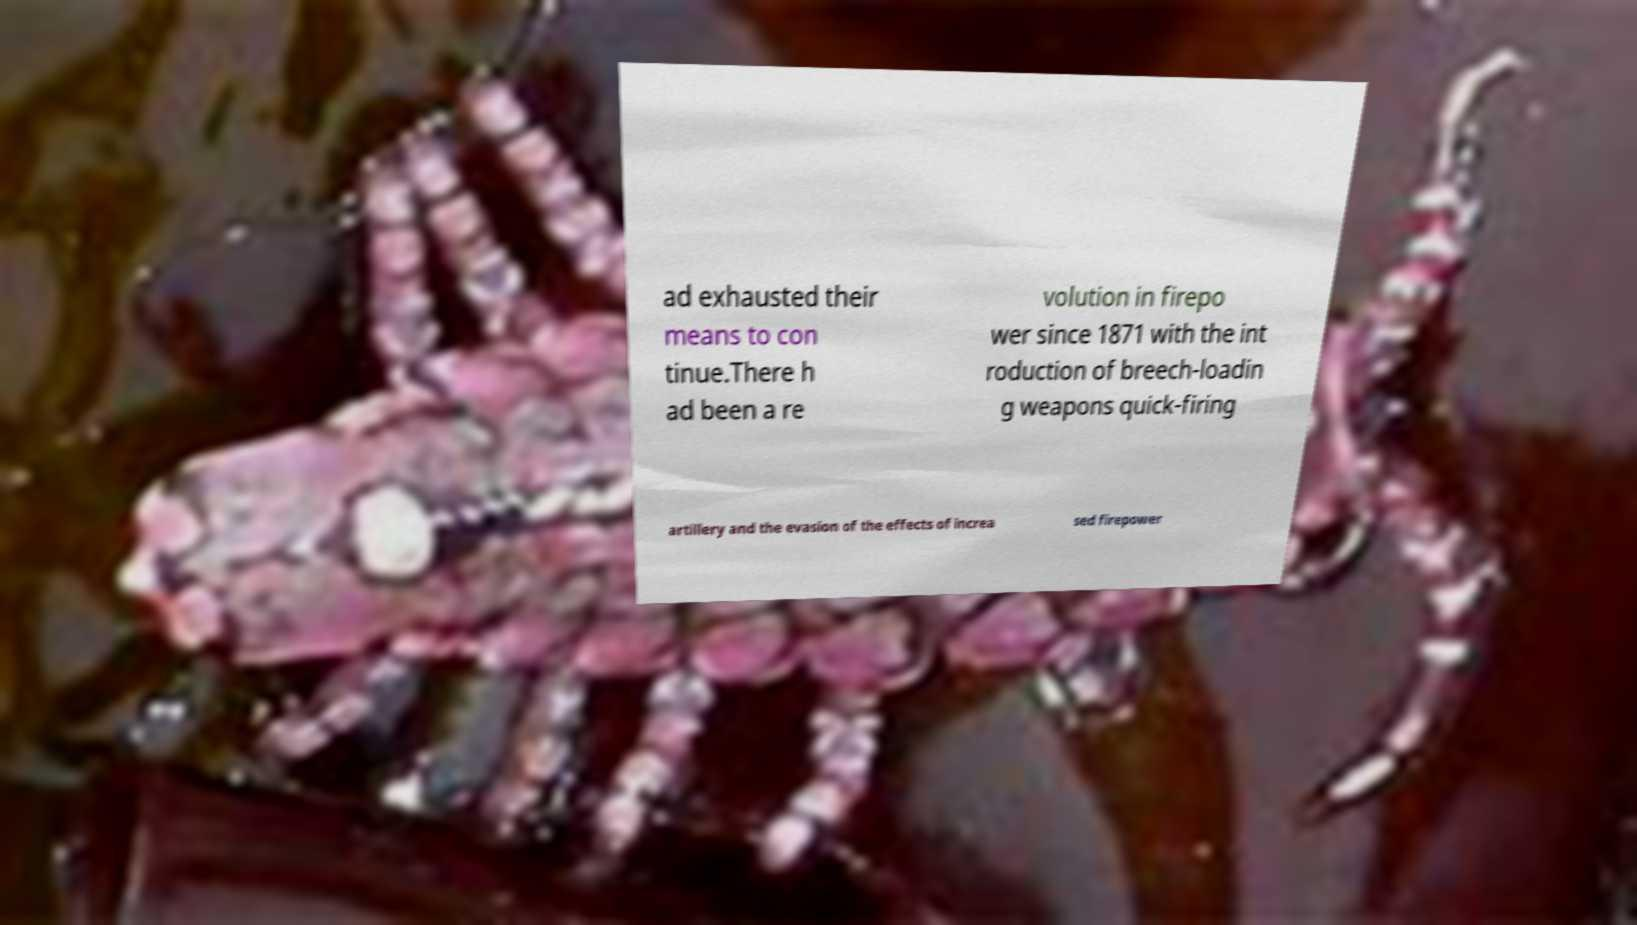Please identify and transcribe the text found in this image. ad exhausted their means to con tinue.There h ad been a re volution in firepo wer since 1871 with the int roduction of breech-loadin g weapons quick-firing artillery and the evasion of the effects of increa sed firepower 